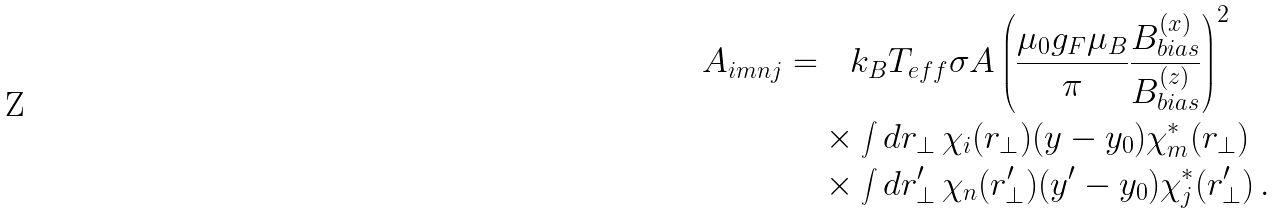Convert formula to latex. <formula><loc_0><loc_0><loc_500><loc_500>A _ { i m n j } = & \quad k _ { B } T _ { e f f } \sigma A \left ( \frac { \mu _ { 0 } g _ { F } \mu _ { B } } { \pi } \frac { B ^ { ( x ) } _ { b i a s } } { B ^ { ( z ) } _ { b i a s } } \right ) ^ { 2 } \\ & \times \int d { r } _ { \perp } \, \chi _ { i } ( { r } _ { \perp } ) ( y - y _ { 0 } ) \chi _ { m } ^ { * } ( { r } _ { \perp } ) \\ & \times \int d { r } ^ { \prime } _ { \perp } \, \chi _ { n } ( { r } ^ { \prime } _ { \perp } ) ( y ^ { \prime } - y _ { 0 } ) \chi _ { j } ^ { * } ( { r } ^ { \prime } _ { \perp } ) \, .</formula> 